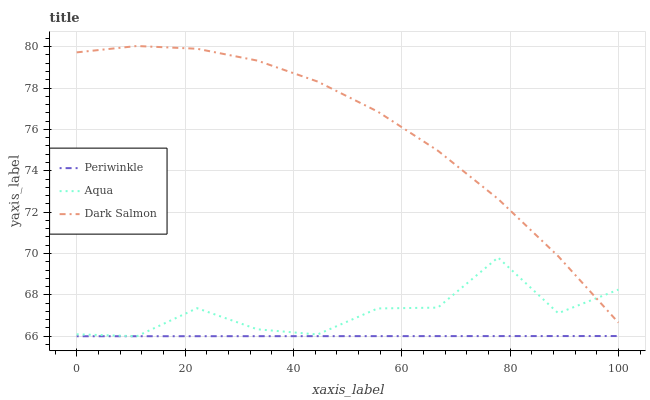Does Periwinkle have the minimum area under the curve?
Answer yes or no. Yes. Does Dark Salmon have the maximum area under the curve?
Answer yes or no. Yes. Does Dark Salmon have the minimum area under the curve?
Answer yes or no. No. Does Periwinkle have the maximum area under the curve?
Answer yes or no. No. Is Periwinkle the smoothest?
Answer yes or no. Yes. Is Aqua the roughest?
Answer yes or no. Yes. Is Dark Salmon the smoothest?
Answer yes or no. No. Is Dark Salmon the roughest?
Answer yes or no. No. Does Aqua have the lowest value?
Answer yes or no. Yes. Does Dark Salmon have the lowest value?
Answer yes or no. No. Does Dark Salmon have the highest value?
Answer yes or no. Yes. Does Periwinkle have the highest value?
Answer yes or no. No. Is Periwinkle less than Dark Salmon?
Answer yes or no. Yes. Is Dark Salmon greater than Periwinkle?
Answer yes or no. Yes. Does Periwinkle intersect Aqua?
Answer yes or no. Yes. Is Periwinkle less than Aqua?
Answer yes or no. No. Is Periwinkle greater than Aqua?
Answer yes or no. No. Does Periwinkle intersect Dark Salmon?
Answer yes or no. No. 